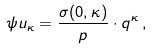Convert formula to latex. <formula><loc_0><loc_0><loc_500><loc_500>\psi u _ { \kappa } = \frac { \sigma ( 0 , \kappa ) } { p } \cdot q ^ { \kappa } \, ,</formula> 